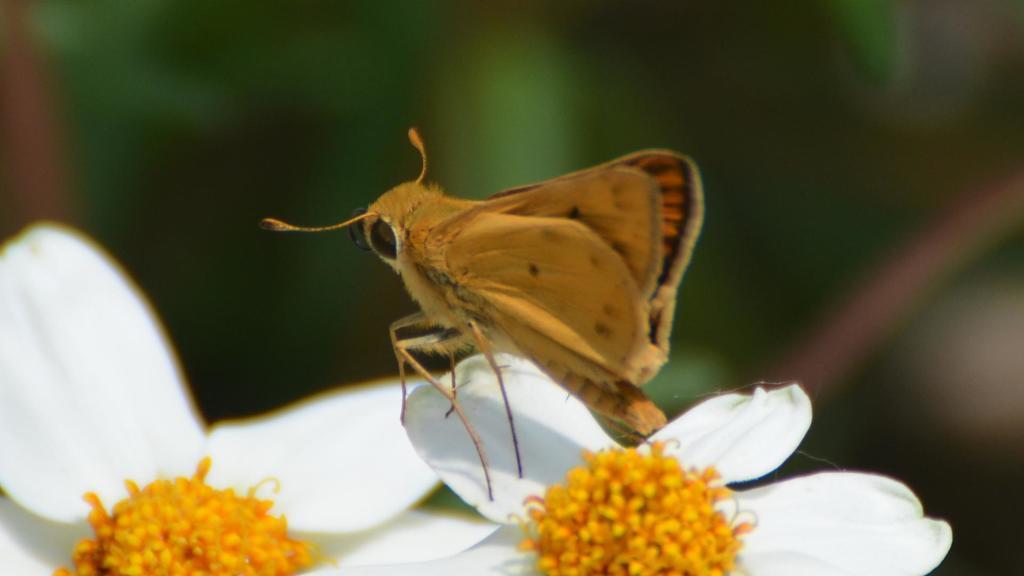Describe this image in one or two sentences. In this picture, we can see an insect on a flower and behind the insect there are blurred things. 